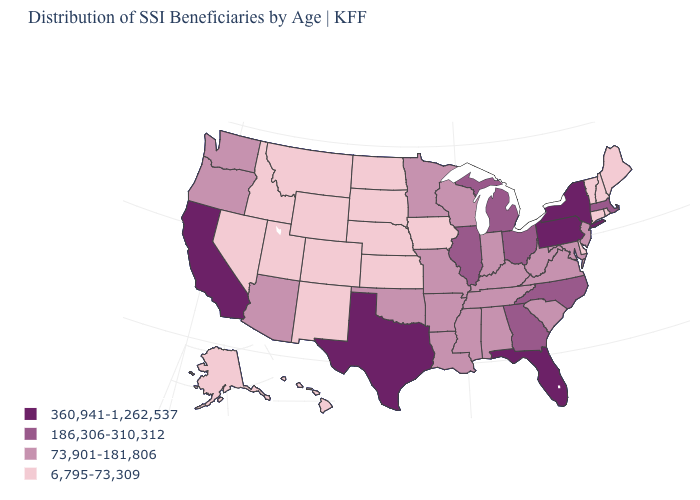What is the lowest value in states that border New York?
Keep it brief. 6,795-73,309. What is the value of Pennsylvania?
Write a very short answer. 360,941-1,262,537. Name the states that have a value in the range 6,795-73,309?
Give a very brief answer. Alaska, Colorado, Connecticut, Delaware, Hawaii, Idaho, Iowa, Kansas, Maine, Montana, Nebraska, Nevada, New Hampshire, New Mexico, North Dakota, Rhode Island, South Dakota, Utah, Vermont, Wyoming. Name the states that have a value in the range 186,306-310,312?
Write a very short answer. Georgia, Illinois, Massachusetts, Michigan, North Carolina, Ohio. What is the highest value in states that border Florida?
Be succinct. 186,306-310,312. What is the value of New York?
Concise answer only. 360,941-1,262,537. Among the states that border Illinois , does Wisconsin have the lowest value?
Concise answer only. No. Name the states that have a value in the range 186,306-310,312?
Answer briefly. Georgia, Illinois, Massachusetts, Michigan, North Carolina, Ohio. Among the states that border Texas , does Oklahoma have the highest value?
Keep it brief. Yes. Does Louisiana have the highest value in the USA?
Answer briefly. No. What is the value of Wyoming?
Quick response, please. 6,795-73,309. Which states hav the highest value in the West?
Be succinct. California. Is the legend a continuous bar?
Be succinct. No. Among the states that border New Mexico , does Utah have the lowest value?
Answer briefly. Yes. What is the highest value in the USA?
Short answer required. 360,941-1,262,537. 